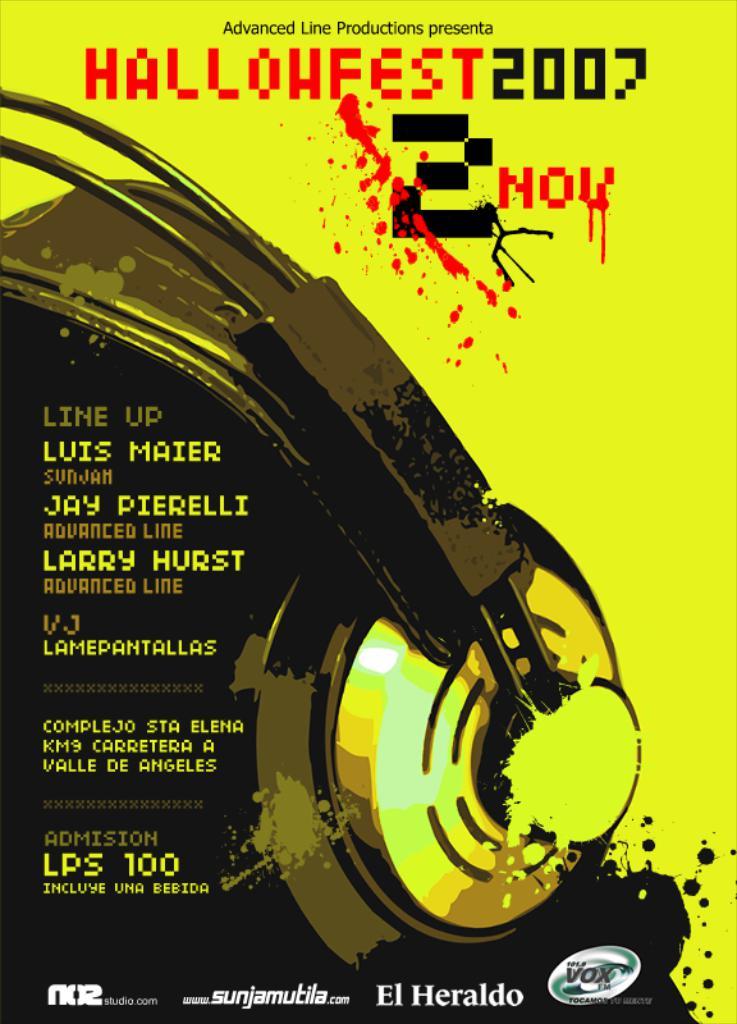What day is hallowfest 2007?
Your answer should be very brief. November 2. What is the admission to hallowfest 2007?
Make the answer very short. 100. 